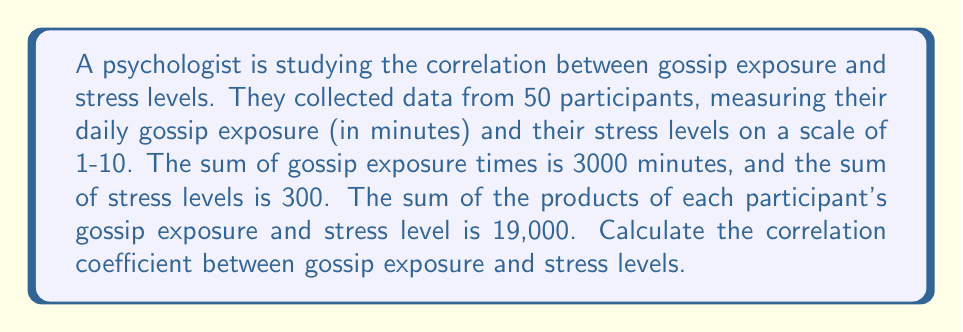What is the answer to this math problem? To calculate the correlation coefficient, we'll use the formula:

$$ r = \frac{n\sum xy - \sum x \sum y}{\sqrt{[n\sum x^2 - (\sum x)^2][n\sum y^2 - (\sum y)^2]}} $$

Where:
$n$ = number of participants = 50
$x$ = gossip exposure time
$y$ = stress level
$\sum x$ = sum of gossip exposure times = 3000
$\sum y$ = sum of stress levels = 300
$\sum xy$ = sum of products of gossip exposure and stress level = 19,000

We need to calculate $\sum x^2$ and $\sum y^2$:

1) Calculate $\overline{x}$ and $\overline{y}$:
   $\overline{x} = \frac{\sum x}{n} = \frac{3000}{50} = 60$
   $\overline{y} = \frac{\sum y}{n} = \frac{300}{50} = 6$

2) Use the formula: $\sum x^2 = n(\overline{x}^2 + s_x^2)$, where $s_x^2$ is the variance of x.
   Similarly for y: $\sum y^2 = n(\overline{y}^2 + s_y^2)$

3) Calculate $s_x^2$ and $s_y^2$ using:
   $s_x^2 = \frac{\sum xy}{n} - \overline{x}\overline{y} = \frac{19000}{50} - 60 \cdot 6 = 380 - 360 = 20$
   $s_y^2 = \frac{\sum y^2}{n} - \overline{y}^2$ (we'll calculate this in the next step)

4) Now we can calculate $\sum x^2$ and $\sum y^2$:
   $\sum x^2 = 50(60^2 + 20) = 50(3600 + 20) = 181,000$
   $\sum y^2 = 50(6^2 + s_y^2) = 50(36 + (\frac{19000}{50} - 60 \cdot 6)) = 50(36 + 20) = 2,800$

5) Substitute all values into the correlation coefficient formula:

$$ r = \frac{50 \cdot 19000 - 3000 \cdot 300}{\sqrt{[50 \cdot 181000 - 3000^2][50 \cdot 2800 - 300^2]}} $$

$$ r = \frac{950000 - 900000}{\sqrt{[9050000 - 9000000][140000 - 90000]}} $$

$$ r = \frac{50000}{\sqrt{50000 \cdot 50000}} = \frac{50000}{50000} = 1 $$
Answer: The correlation coefficient between gossip exposure and stress levels is 1, indicating a perfect positive linear correlation. 